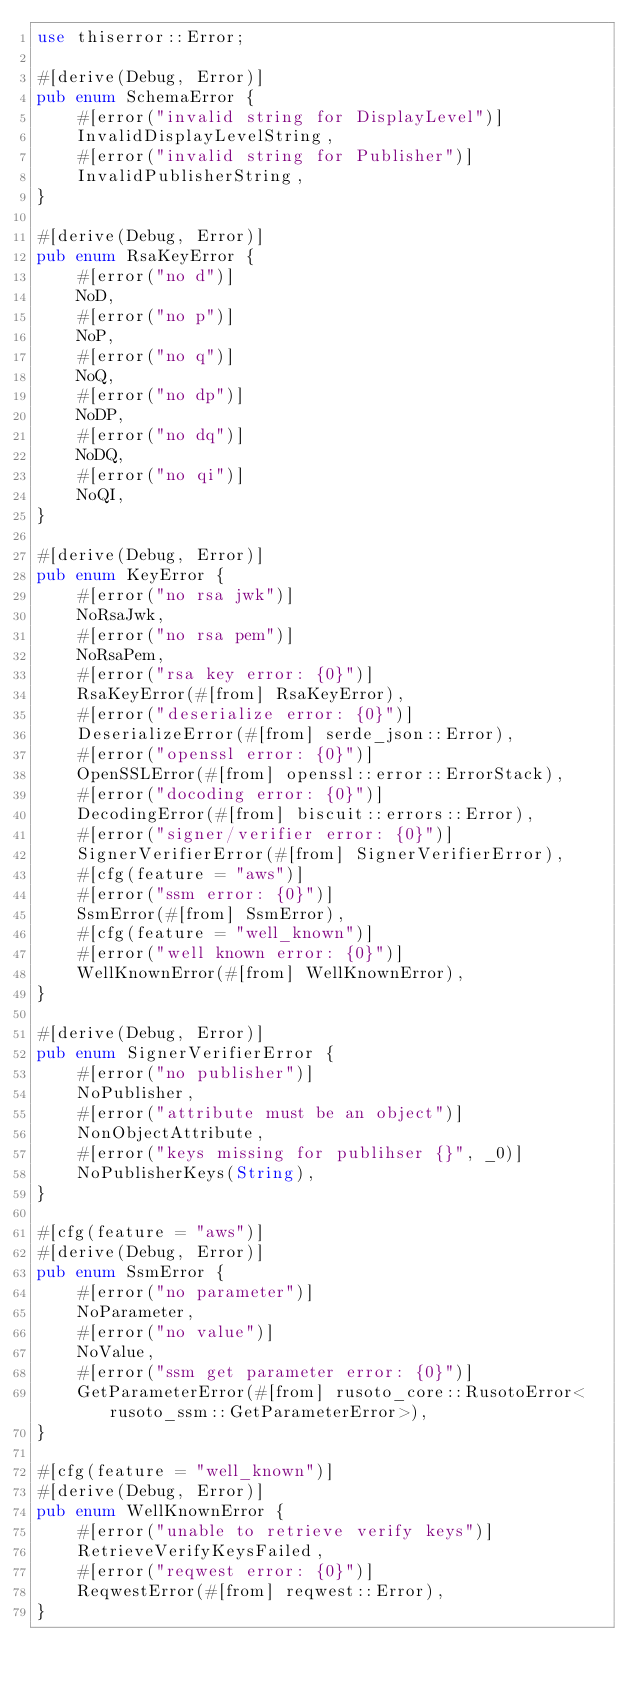<code> <loc_0><loc_0><loc_500><loc_500><_Rust_>use thiserror::Error;

#[derive(Debug, Error)]
pub enum SchemaError {
    #[error("invalid string for DisplayLevel")]
    InvalidDisplayLevelString,
    #[error("invalid string for Publisher")]
    InvalidPublisherString,
}

#[derive(Debug, Error)]
pub enum RsaKeyError {
    #[error("no d")]
    NoD,
    #[error("no p")]
    NoP,
    #[error("no q")]
    NoQ,
    #[error("no dp")]
    NoDP,
    #[error("no dq")]
    NoDQ,
    #[error("no qi")]
    NoQI,
}

#[derive(Debug, Error)]
pub enum KeyError {
    #[error("no rsa jwk")]
    NoRsaJwk,
    #[error("no rsa pem")]
    NoRsaPem,
    #[error("rsa key error: {0}")]
    RsaKeyError(#[from] RsaKeyError),
    #[error("deserialize error: {0}")]
    DeserializeError(#[from] serde_json::Error),
    #[error("openssl error: {0}")]
    OpenSSLError(#[from] openssl::error::ErrorStack),
    #[error("docoding error: {0}")]
    DecodingError(#[from] biscuit::errors::Error),
    #[error("signer/verifier error: {0}")]
    SignerVerifierError(#[from] SignerVerifierError),
    #[cfg(feature = "aws")]
    #[error("ssm error: {0}")]
    SsmError(#[from] SsmError),
    #[cfg(feature = "well_known")]
    #[error("well known error: {0}")]
    WellKnownError(#[from] WellKnownError),
}

#[derive(Debug, Error)]
pub enum SignerVerifierError {
    #[error("no publisher")]
    NoPublisher,
    #[error("attribute must be an object")]
    NonObjectAttribute,
    #[error("keys missing for publihser {}", _0)]
    NoPublisherKeys(String),
}

#[cfg(feature = "aws")]
#[derive(Debug, Error)]
pub enum SsmError {
    #[error("no parameter")]
    NoParameter,
    #[error("no value")]
    NoValue,
    #[error("ssm get parameter error: {0}")]
    GetParameterError(#[from] rusoto_core::RusotoError<rusoto_ssm::GetParameterError>),
}

#[cfg(feature = "well_known")]
#[derive(Debug, Error)]
pub enum WellKnownError {
    #[error("unable to retrieve verify keys")]
    RetrieveVerifyKeysFailed,
    #[error("reqwest error: {0}")]
    ReqwestError(#[from] reqwest::Error),
}
</code> 